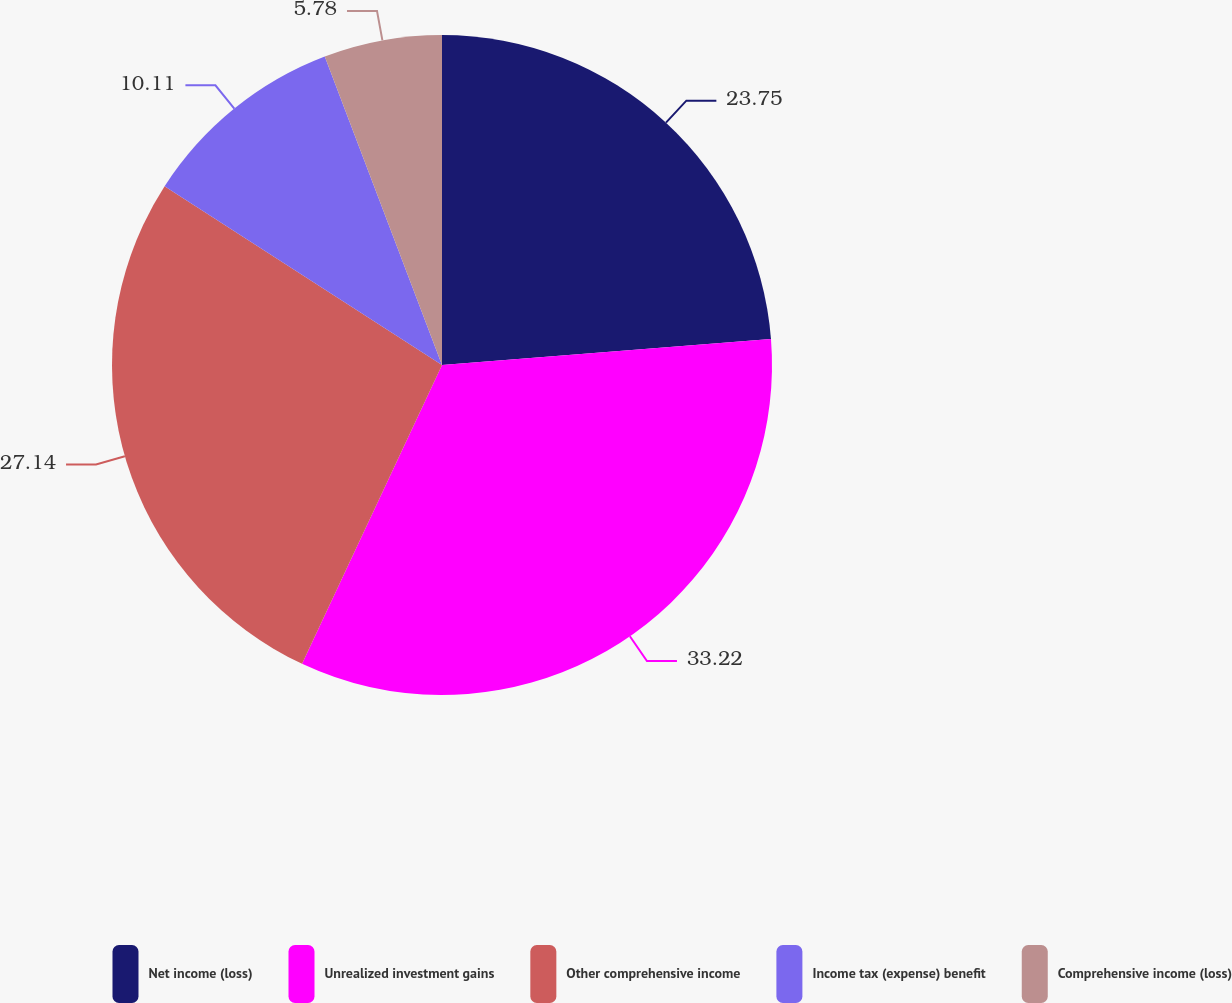Convert chart. <chart><loc_0><loc_0><loc_500><loc_500><pie_chart><fcel>Net income (loss)<fcel>Unrealized investment gains<fcel>Other comprehensive income<fcel>Income tax (expense) benefit<fcel>Comprehensive income (loss)<nl><fcel>23.75%<fcel>33.22%<fcel>27.14%<fcel>10.11%<fcel>5.78%<nl></chart> 